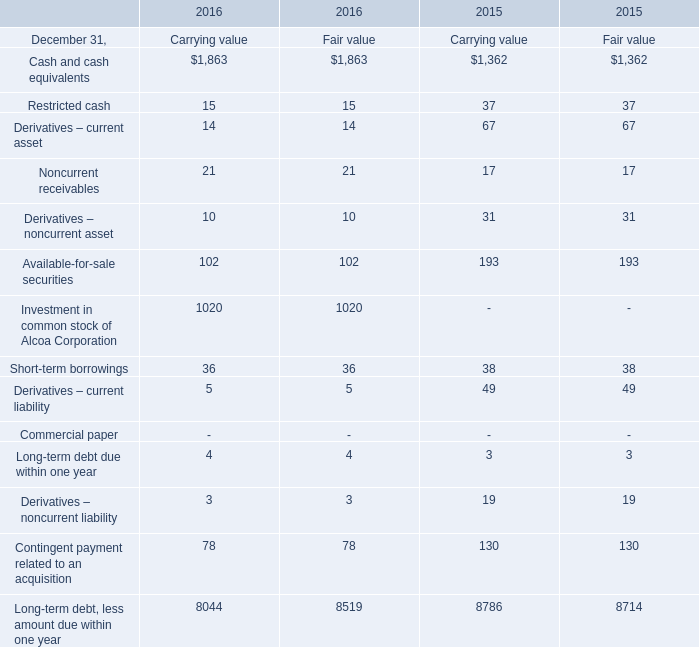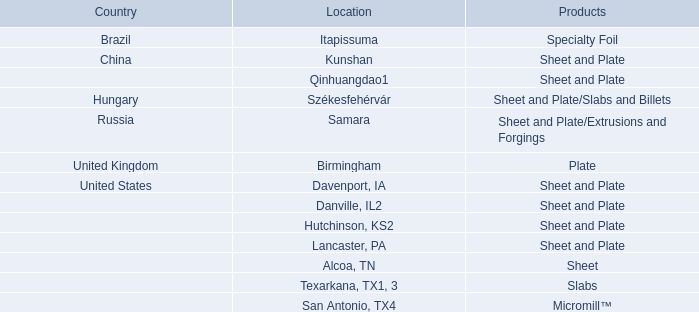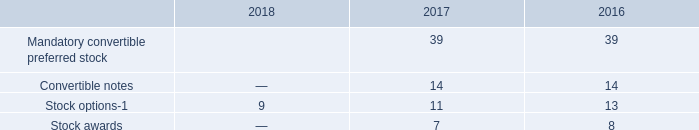considering the average exercise price of options , what is the increase in the total value of stock options observed during 2016 and 2017 , in millions of dollars? 
Computations: ((11 * 33.32) - (13 * 26.93))
Answer: 16.43. 